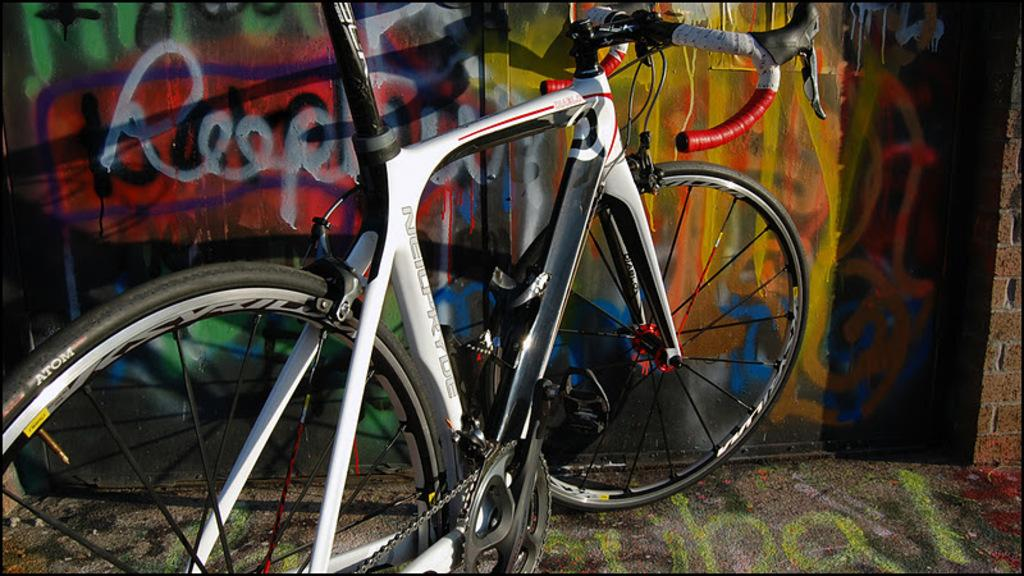Where was the picture taken? The picture was taken outside. What can be seen in the image besides the outdoor setting? There is a white color bicycle in the image. How is the bicycle positioned in the image? The bicycle is parked on the ground. What can be seen in the background of the image? There is a wall in the background of the image, and there is graffiti art on the wall. What type of plantation can be seen in the image? There is no plantation present in the image; it features a parked bicycle and a wall with graffiti art in the background. 